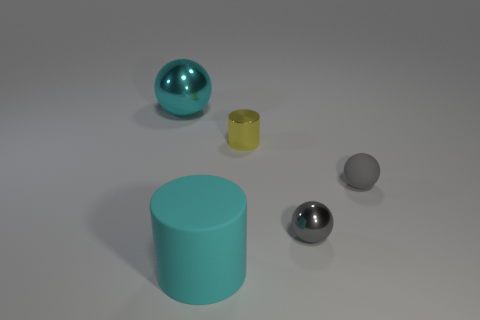Subtract all tiny metal balls. How many balls are left? 2 Subtract all red cubes. How many gray balls are left? 2 Add 1 small yellow cylinders. How many objects exist? 6 Subtract all balls. How many objects are left? 2 Subtract all purple balls. Subtract all green cubes. How many balls are left? 3 Subtract all big objects. Subtract all gray metallic spheres. How many objects are left? 2 Add 4 shiny things. How many shiny things are left? 7 Add 2 small matte objects. How many small matte objects exist? 3 Subtract 0 red blocks. How many objects are left? 5 